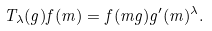<formula> <loc_0><loc_0><loc_500><loc_500>T _ { \lambda } ( g ) f ( m ) = f ( m g ) g ^ { \prime } ( m ) ^ { \lambda } .</formula> 